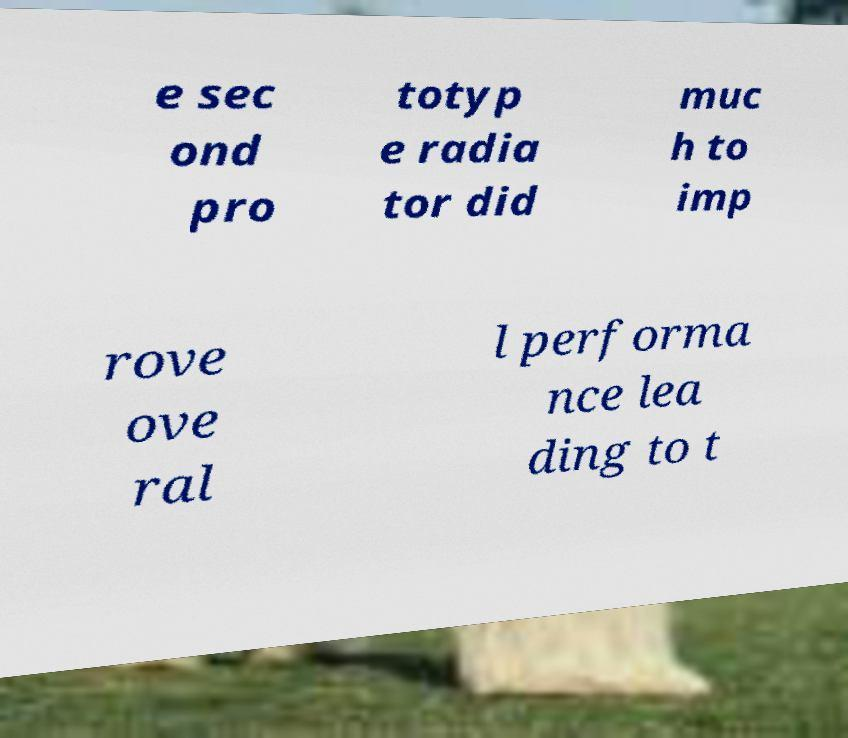Please identify and transcribe the text found in this image. e sec ond pro totyp e radia tor did muc h to imp rove ove ral l performa nce lea ding to t 